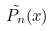<formula> <loc_0><loc_0><loc_500><loc_500>\tilde { P _ { n } } ( x )</formula> 